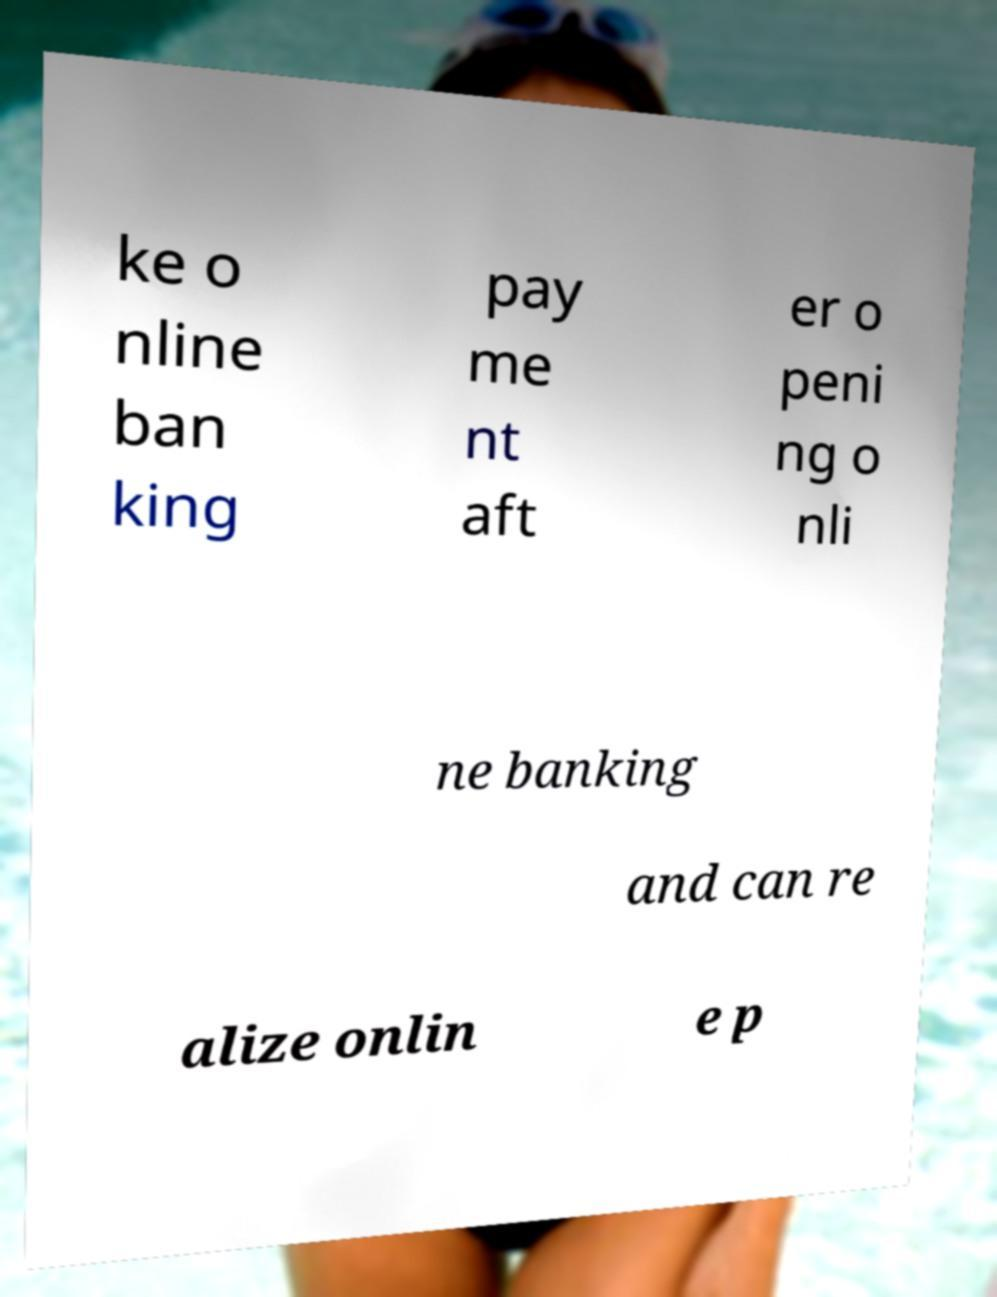I need the written content from this picture converted into text. Can you do that? ke o nline ban king pay me nt aft er o peni ng o nli ne banking and can re alize onlin e p 